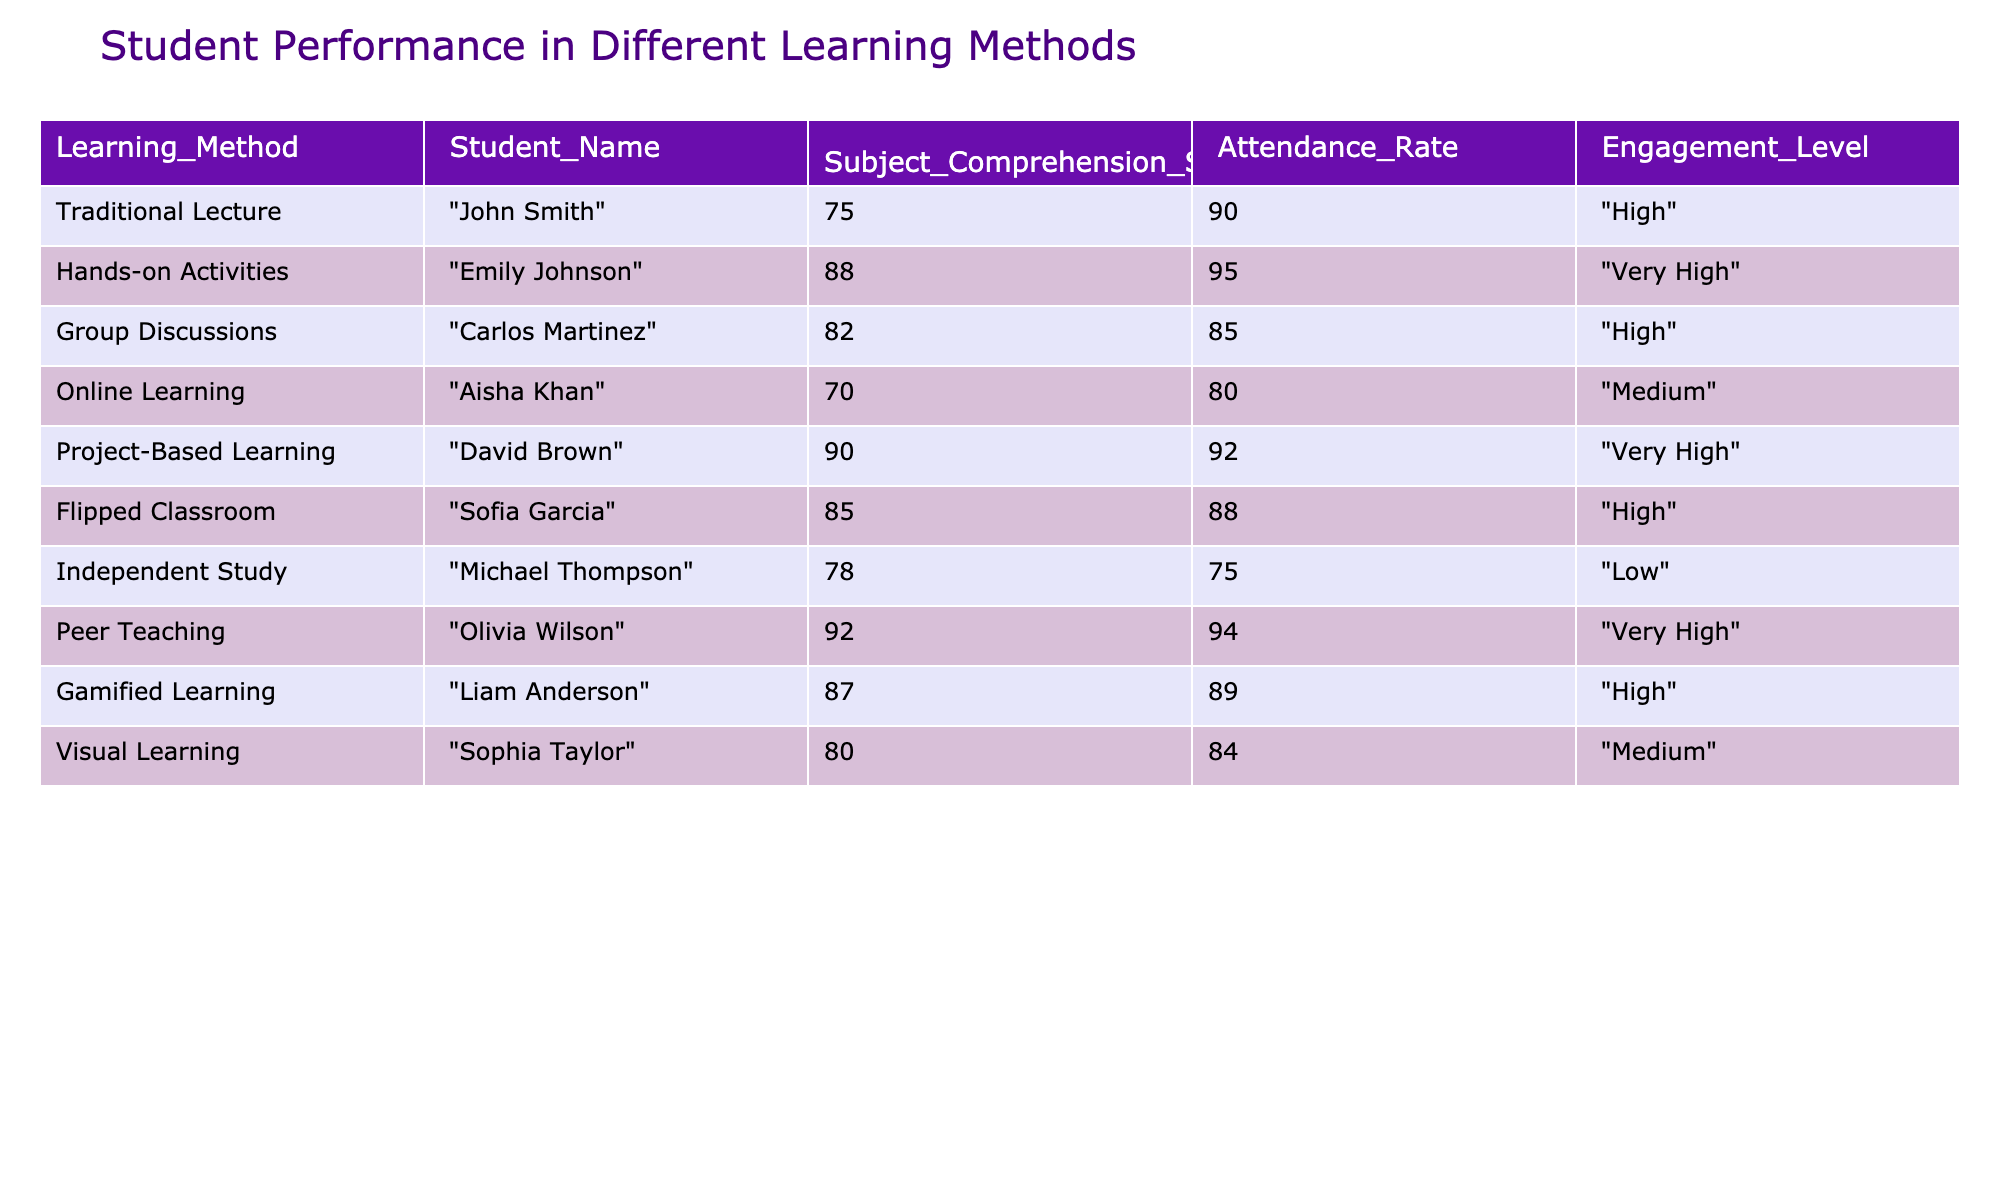What is the highest Subject Comprehension Score in the table? The table lists different Student Names along with their Subject Comprehension Scores. By examining the scores, I see that 'Olivia Wilson' has the highest score at 92.
Answer: 92 Which learning method has the lowest Attendance Rate? By checking the Attendance Rate for each learning method, I find that 'Independent Study' has the lowest rate at 75%.
Answer: 75% What is the average Subject Comprehension Score for students with a "Very High" Engagement Level? The students with a "Very High" Engagement Level are 'Emily Johnson', 'David Brown', and 'Olivia Wilson' with scores of 88, 90, and 92. Adding them gives 88 + 90 + 92 = 270. The average score is 270 divided by 3, resulting in 90.
Answer: 90 Is the Engagement Level correlated with the Subject Comprehension Score? To determine correlation, we check each learning method's Engagement Level against the average scores. Students with higher Engagement Levels like 'Olivia Wilson' and 'Emily Johnson' have higher scores, while those with lower Engagement Levels, like 'Michael Thompson', have relatively lower scores. This suggests a positive correlation.
Answer: Yes Which learning method has the best combination of high Subject Comprehension Score and Attendance Rate? To find this out, I review each method's Subject Comprehension Score along with its Attendance Rate. 'Peer Teaching' has a score of 92 and an Attendance Rate of 94, which appears to be the highest combination compared to others.
Answer: Peer Teaching What learning method is associated with the lowest score among students with high Attendance Rates? Among those with high Attendance Rates (above 90%), 'John Smith' from 'Traditional Lecture' has a score of 75, which is the lowest compared to others in the same attendance range.
Answer: Traditional Lecture What is the difference in Subject Comprehension Scores between 'Gamified Learning' and 'Online Learning'? The Subject Comprehension Score for 'Gamified Learning' (87) minus the score for 'Online Learning' (70) equals 17. This is a straightforward subtraction to find the difference.
Answer: 17 Are there any students who scored above 85 while having an Attendance Rate below 90? Reviewing the table, 'Sofia Garcia' scored 85 but with an Attendance Rate of 88, which is still not below 90. No students meet the criteria of scoring above 85 while being below 90 in attendance.
Answer: No 